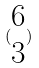<formula> <loc_0><loc_0><loc_500><loc_500>( \begin{matrix} 6 \\ 3 \end{matrix} )</formula> 